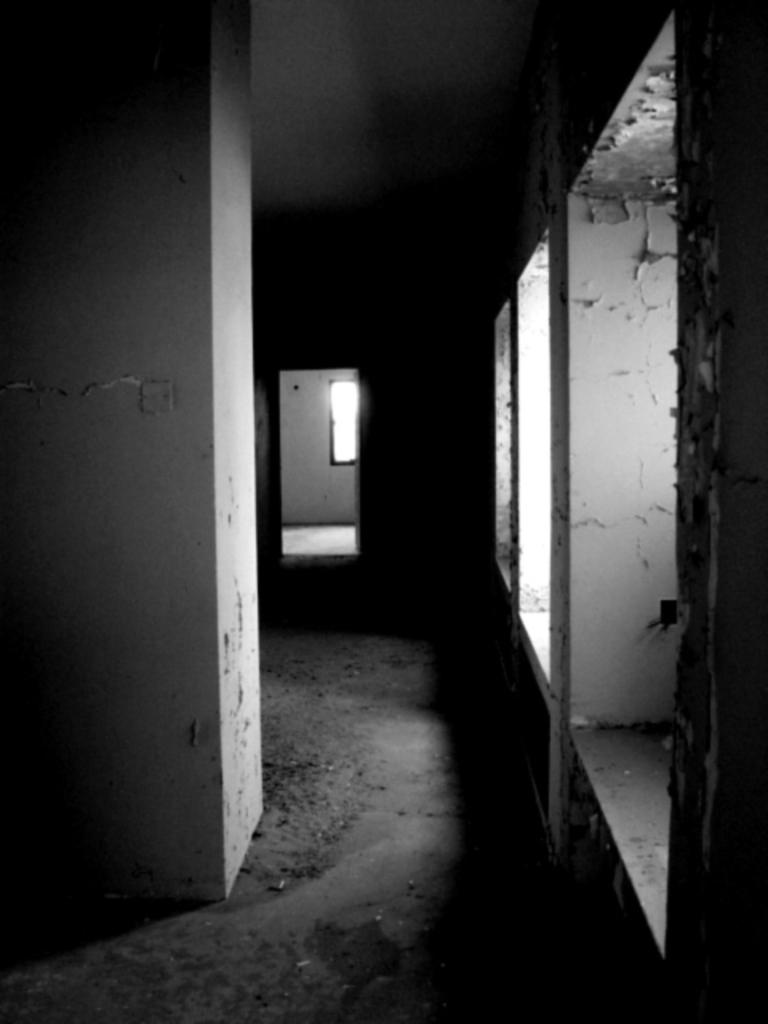What is the color scheme of the image? The image is black and white. What architectural feature can be seen in the image? There is a window in the image. What structural element is present in the image? There is a pillar in the image. What part of a building is visible in the image? There is a roof in the image. What type of surface is shown in the image? There is a wall in the image. How does the popcorn fold and stretch in the image? There is no popcorn present in the image, so the folding and stretching of popcorn cannot be observed. 